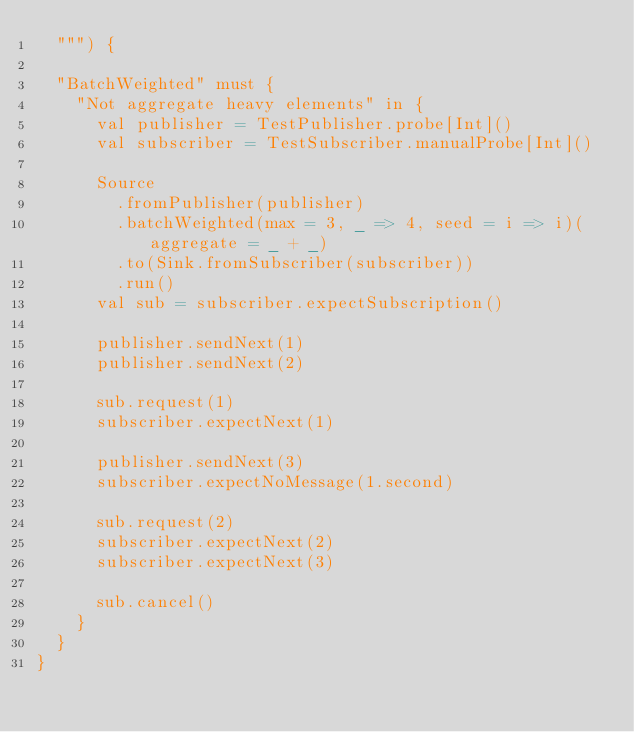Convert code to text. <code><loc_0><loc_0><loc_500><loc_500><_Scala_>  """) {

  "BatchWeighted" must {
    "Not aggregate heavy elements" in {
      val publisher = TestPublisher.probe[Int]()
      val subscriber = TestSubscriber.manualProbe[Int]()

      Source
        .fromPublisher(publisher)
        .batchWeighted(max = 3, _ => 4, seed = i => i)(aggregate = _ + _)
        .to(Sink.fromSubscriber(subscriber))
        .run()
      val sub = subscriber.expectSubscription()

      publisher.sendNext(1)
      publisher.sendNext(2)

      sub.request(1)
      subscriber.expectNext(1)

      publisher.sendNext(3)
      subscriber.expectNoMessage(1.second)

      sub.request(2)
      subscriber.expectNext(2)
      subscriber.expectNext(3)

      sub.cancel()
    }
  }
}
</code> 